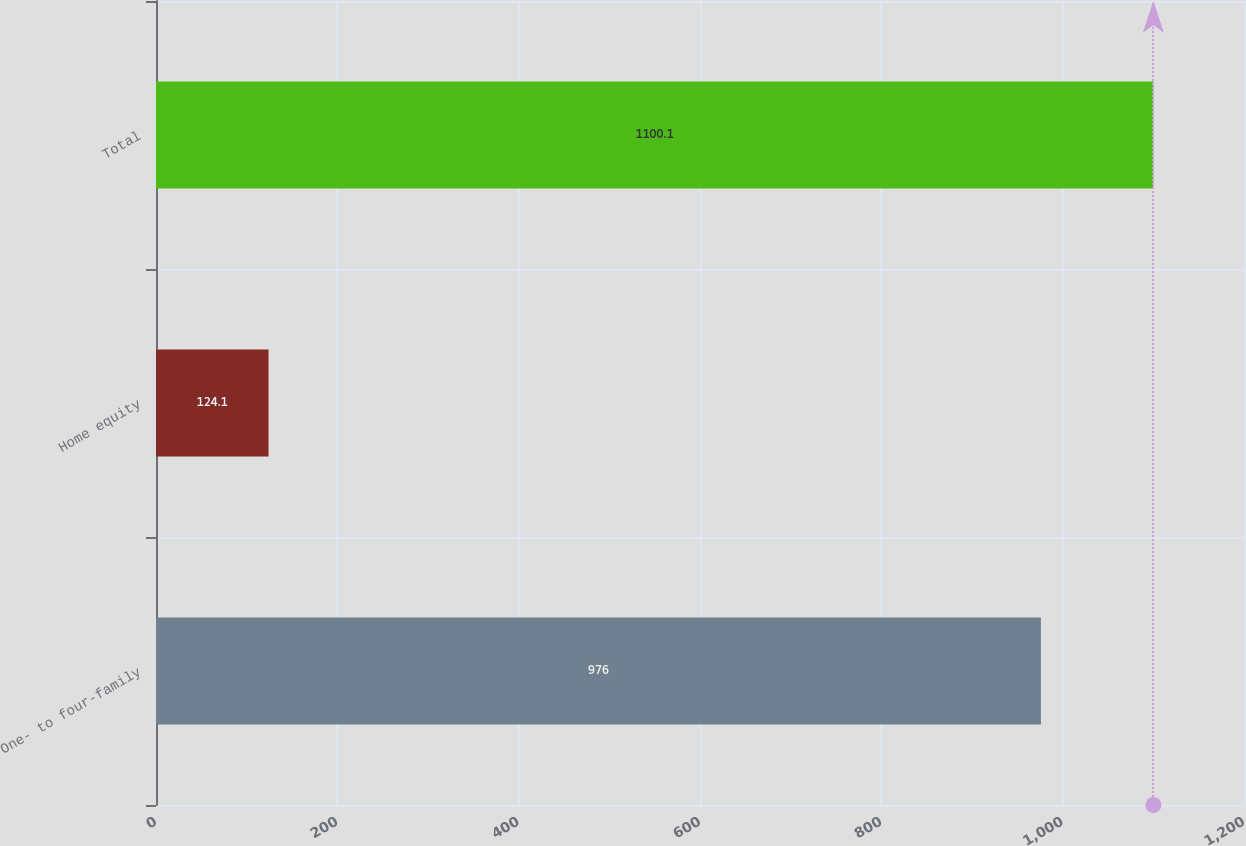Convert chart to OTSL. <chart><loc_0><loc_0><loc_500><loc_500><bar_chart><fcel>One- to four-family<fcel>Home equity<fcel>Total<nl><fcel>976<fcel>124.1<fcel>1100.1<nl></chart> 